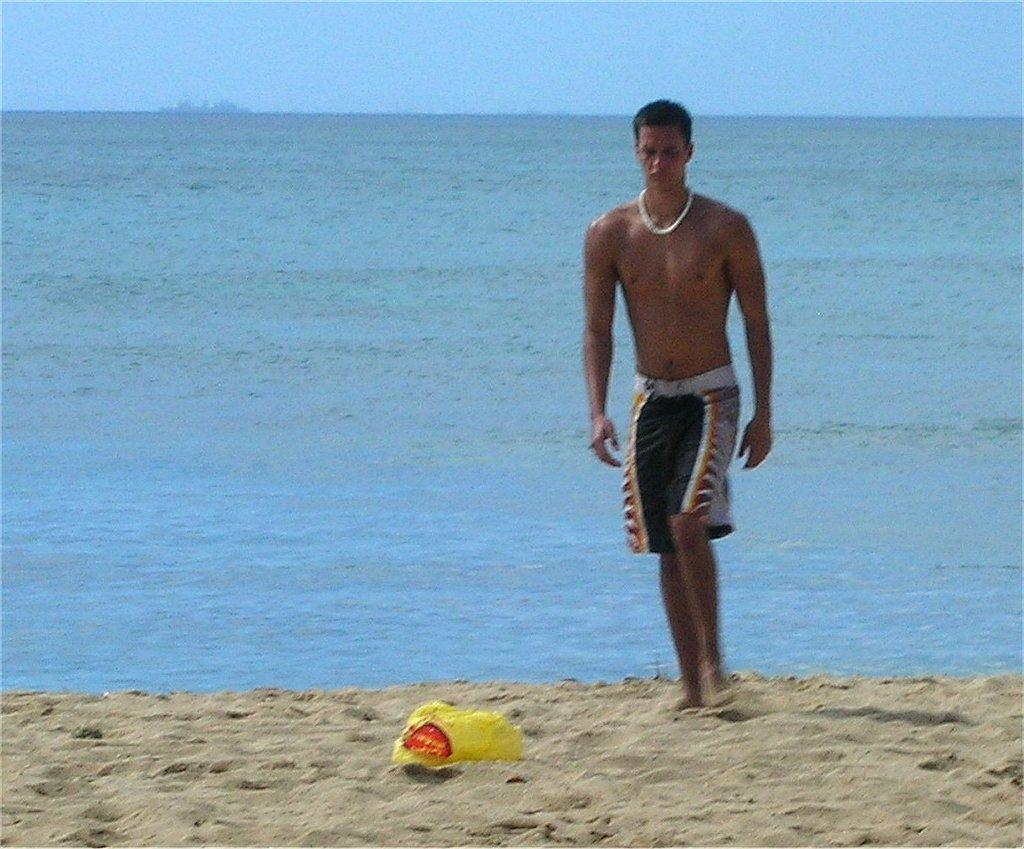Describe this image in one or two sentences. In the image we can see there is a man standing near the sea shore and there is a basket on the sand. There is a clear sky. 